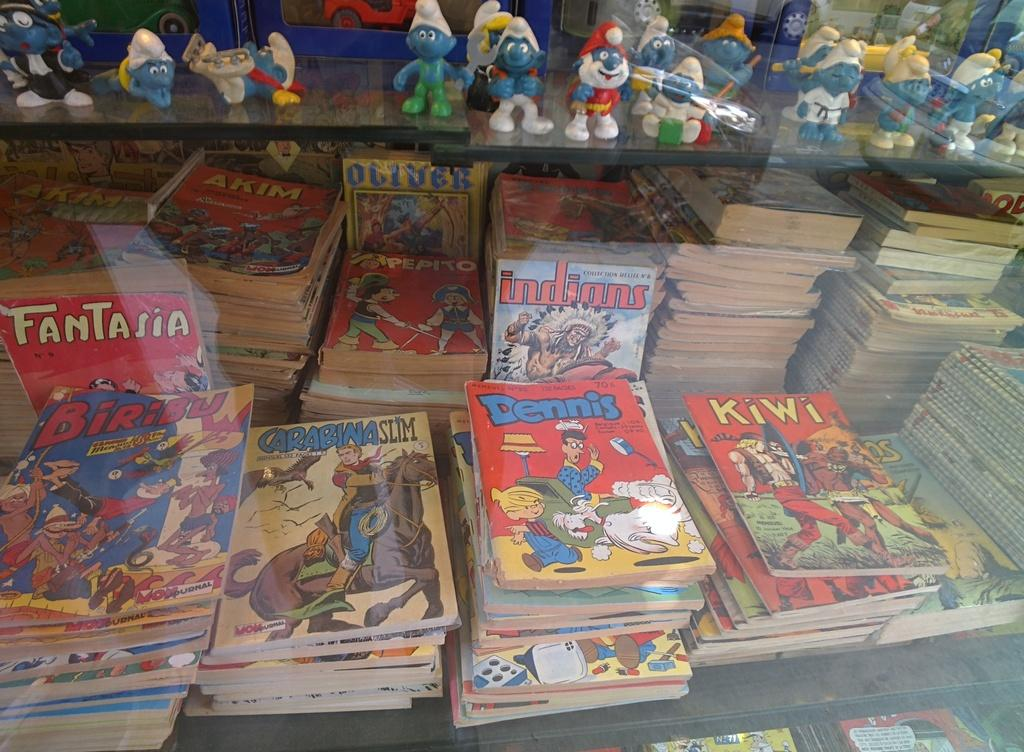<image>
Give a short and clear explanation of the subsequent image. I collection of old comic books, including Fantasia and Dennis the Menace. 